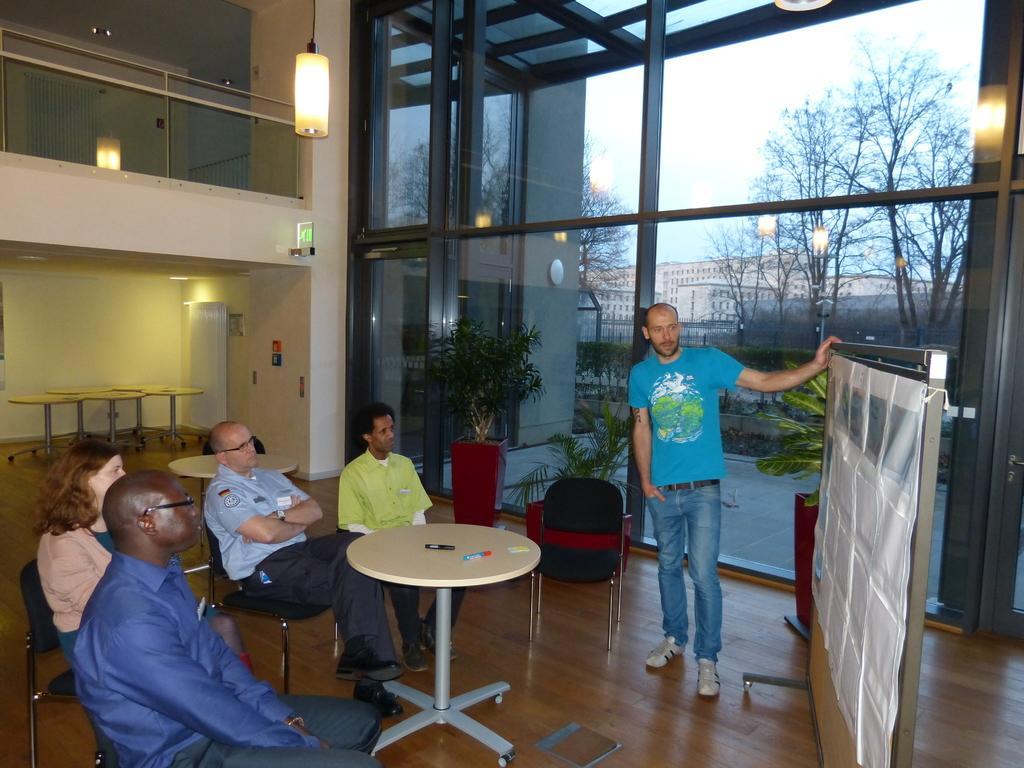Can you describe this image briefly? In this we can see four people are sitting on the chairs and a man wearing blue shirt is standing and looking at the board. In the background of the image we can see glass windows through which buildings and trees are seen. 